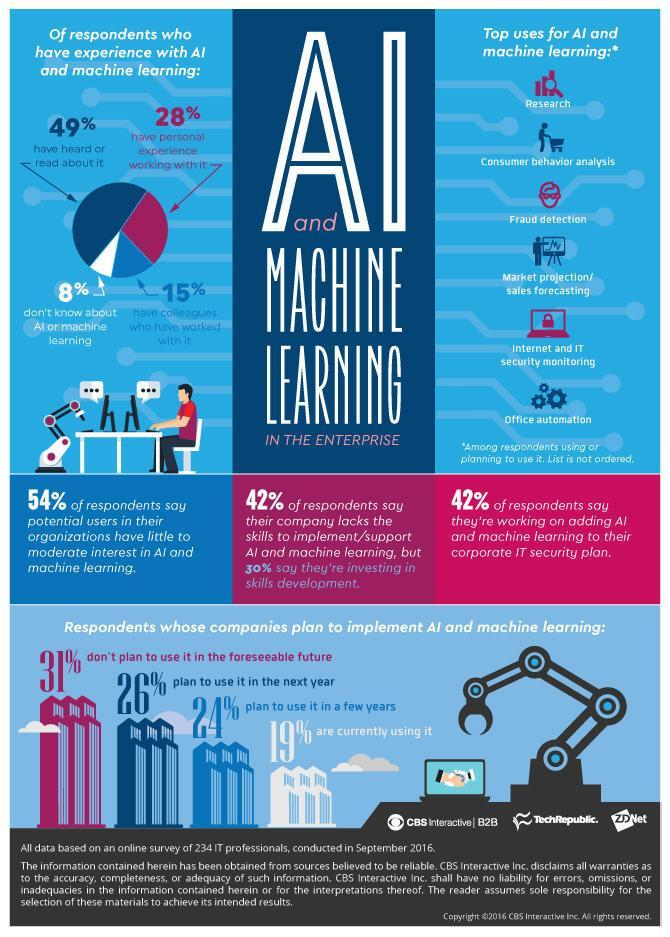What is the percentage of respondents whose companies are currently using AI & machine learning based on the survey conducted in September 2016?
Answer the question with a short phrase. 19% What percentage of respondents have personal experience working with AI & machine learning based on the survey conducted in September 2016? 28% What is the percentage of respondents whose companies plan to use AI & machine learning in the next year based on the survey conducted in September 2016? 26% What percentage of respondents have no idea about AI & machine learning based on the survey conducted in September 2016? 8% 